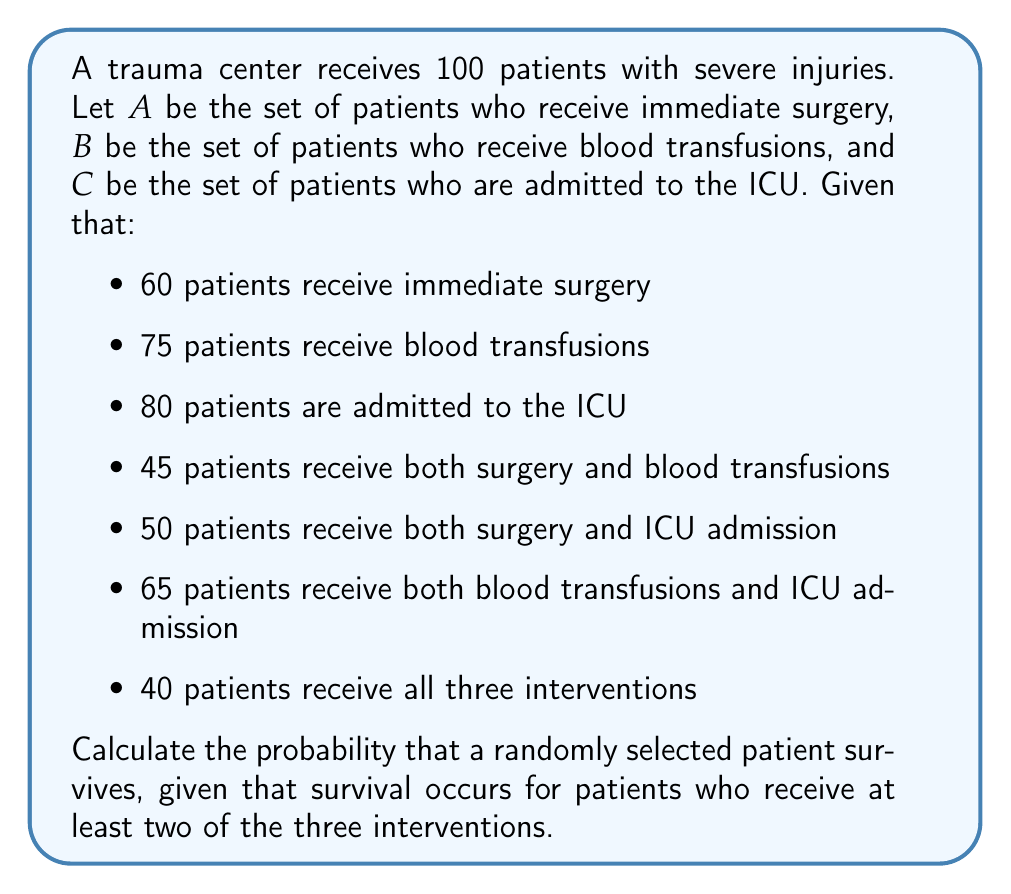Give your solution to this math problem. To solve this problem, we'll use set theory and probability concepts:

1) First, let's find the number of patients who receive at least two interventions. This can be calculated using the inclusion-exclusion principle:

   $$ |A \cup B \cup C| = |A| + |B| + |C| - |A \cap B| - |A \cap C| - |B \cap C| + |A \cap B \cap C| $$

2) We're given all these values:
   $|A| = 60$, $|B| = 75$, $|C| = 80$
   $|A \cap B| = 45$, $|A \cap C| = 50$, $|B \cap C| = 65$
   $|A \cap B \cap C| = 40$

3) Substituting these into the formula:

   $$ |A \cup B \cup C| = 60 + 75 + 80 - 45 - 50 - 65 + 40 = 95 $$

4) Now, we need to find the number of patients who receive exactly one intervention:
   $$ |(A \cup B \cup C)^c| = 100 - 95 = 5 $$

5) The number of patients who receive at least two interventions is:
   $$ |A \cap B| + |A \cap C| + |B \cap C| - 2|A \cap B \cap C| $$
   $$ = 45 + 50 + 65 - 2(40) = 80 $$

6) The probability of survival is thus:

   $$ P(\text{survival}) = \frac{\text{patients receiving at least two interventions}}{\text{total patients}} = \frac{80}{100} = 0.8 $$
Answer: The probability that a randomly selected patient survives is $0.8$ or $80\%$. 